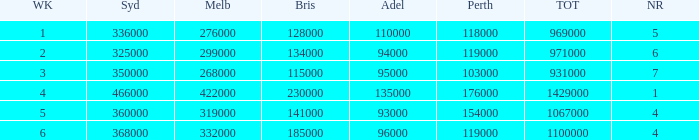Can you parse all the data within this table? {'header': ['WK', 'Syd', 'Melb', 'Bris', 'Adel', 'Perth', 'TOT', 'NR'], 'rows': [['1', '336000', '276000', '128000', '110000', '118000', '969000', '5'], ['2', '325000', '299000', '134000', '94000', '119000', '971000', '6'], ['3', '350000', '268000', '115000', '95000', '103000', '931000', '7'], ['4', '466000', '422000', '230000', '135000', '176000', '1429000', '1'], ['5', '360000', '319000', '141000', '93000', '154000', '1067000', '4'], ['6', '368000', '332000', '185000', '96000', '119000', '1100000', '4']]} What was the rating for Brisbane the week that Adelaide had 94000? 134000.0. 